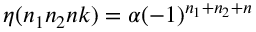<formula> <loc_0><loc_0><loc_500><loc_500>\eta ( n _ { 1 } n _ { 2 } n k ) = \alpha ( - 1 ) ^ { n _ { 1 } + n _ { 2 } + n }</formula> 